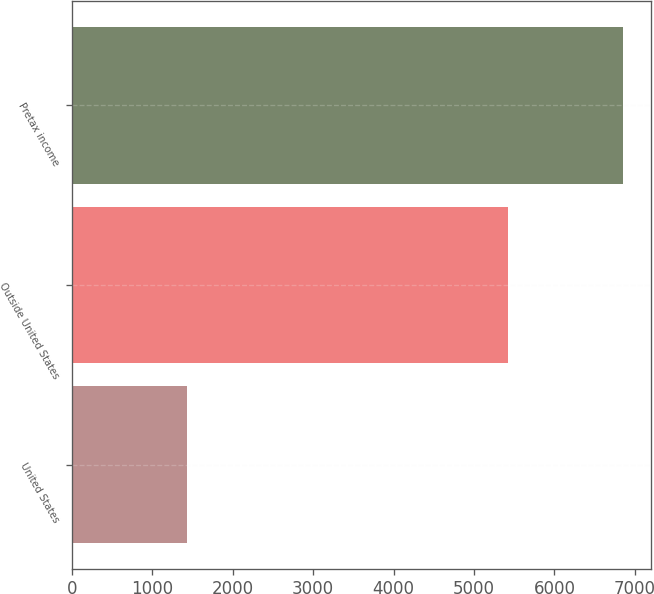Convert chart to OTSL. <chart><loc_0><loc_0><loc_500><loc_500><bar_chart><fcel>United States<fcel>Outside United States<fcel>Pretax income<nl><fcel>1432<fcel>5420<fcel>6852<nl></chart> 